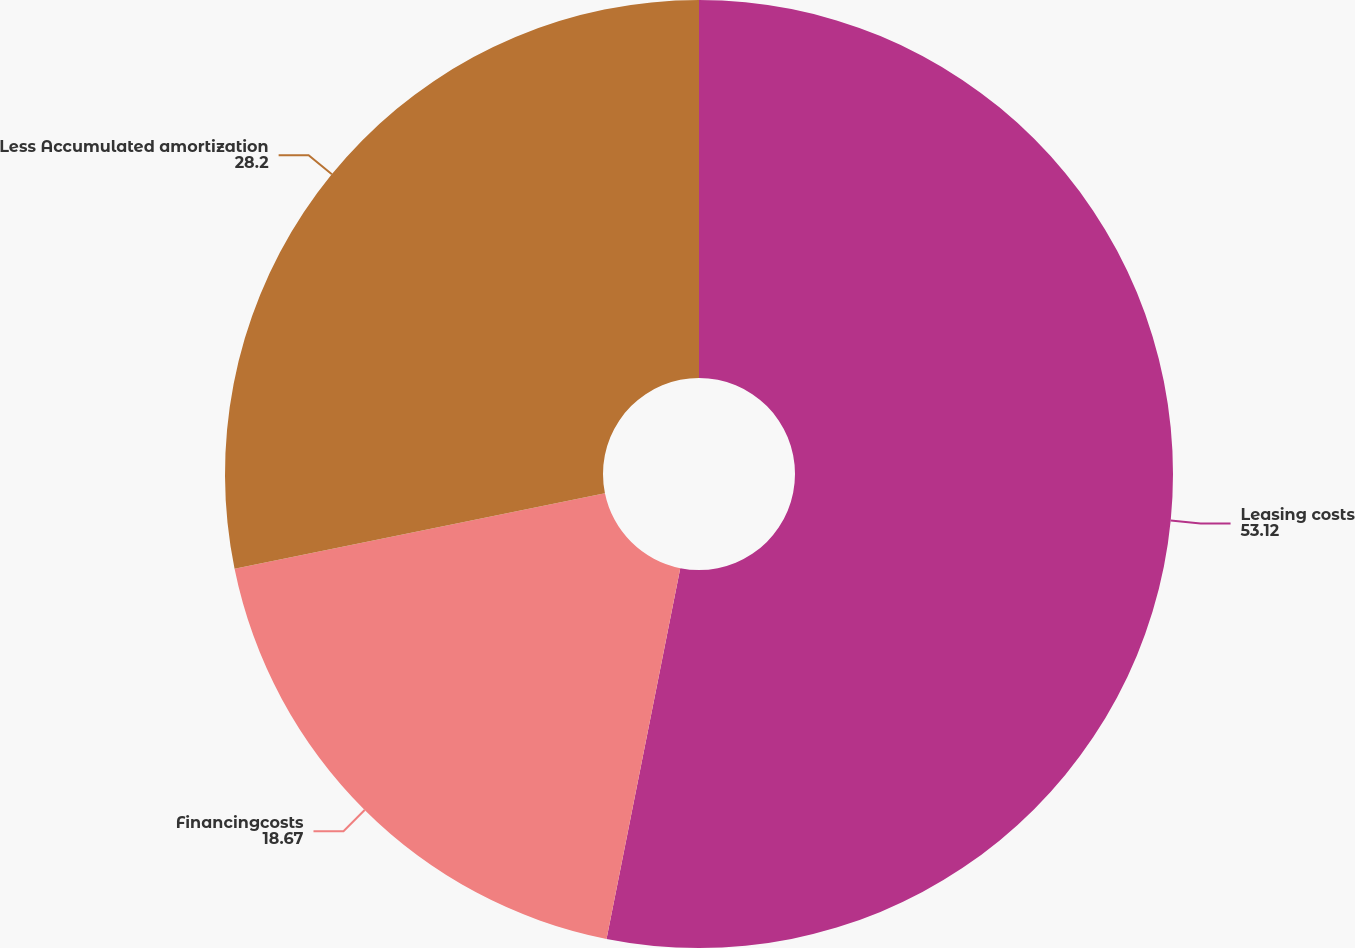<chart> <loc_0><loc_0><loc_500><loc_500><pie_chart><fcel>Leasing costs<fcel>Financingcosts<fcel>Less Accumulated amortization<nl><fcel>53.12%<fcel>18.67%<fcel>28.2%<nl></chart> 